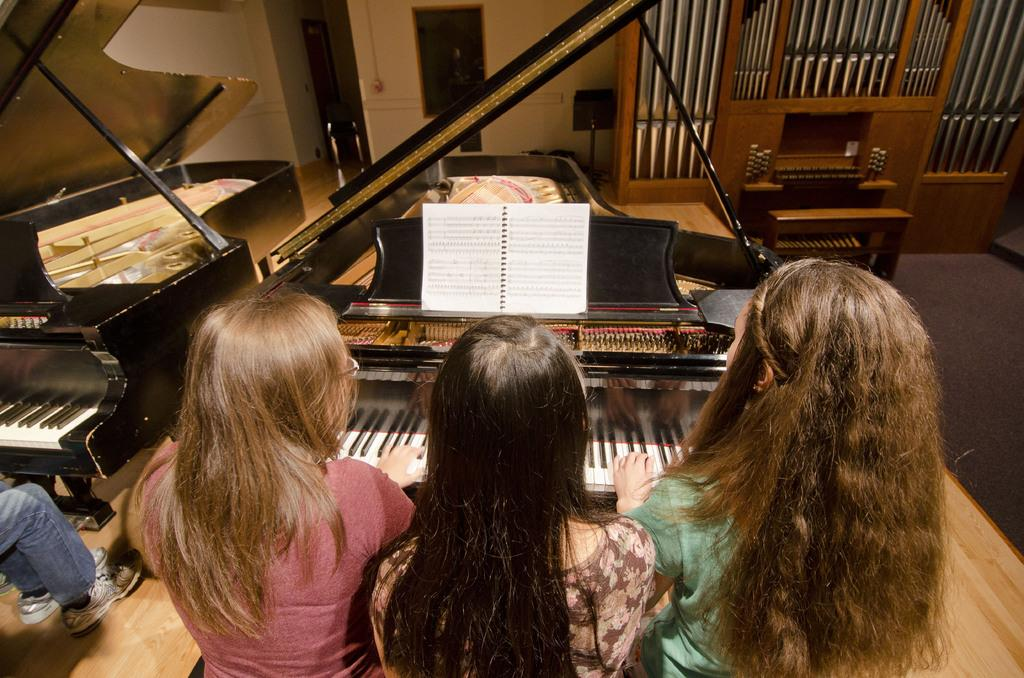How many people are in the image? There are three women in the image. Can you describe the setting of the image? The individuals are sitting in front of pianos. What else can be seen in the image besides the people and pianos? There is a book visible in the image. What type of grass is growing on the pianos in the image? There is no grass present in the image; the individuals are sitting in front of pianos. 